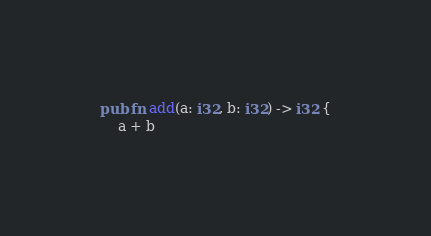Convert code to text. <code><loc_0><loc_0><loc_500><loc_500><_Rust_>pub fn add(a: i32, b: i32) -> i32 {
    a + b
</code> 